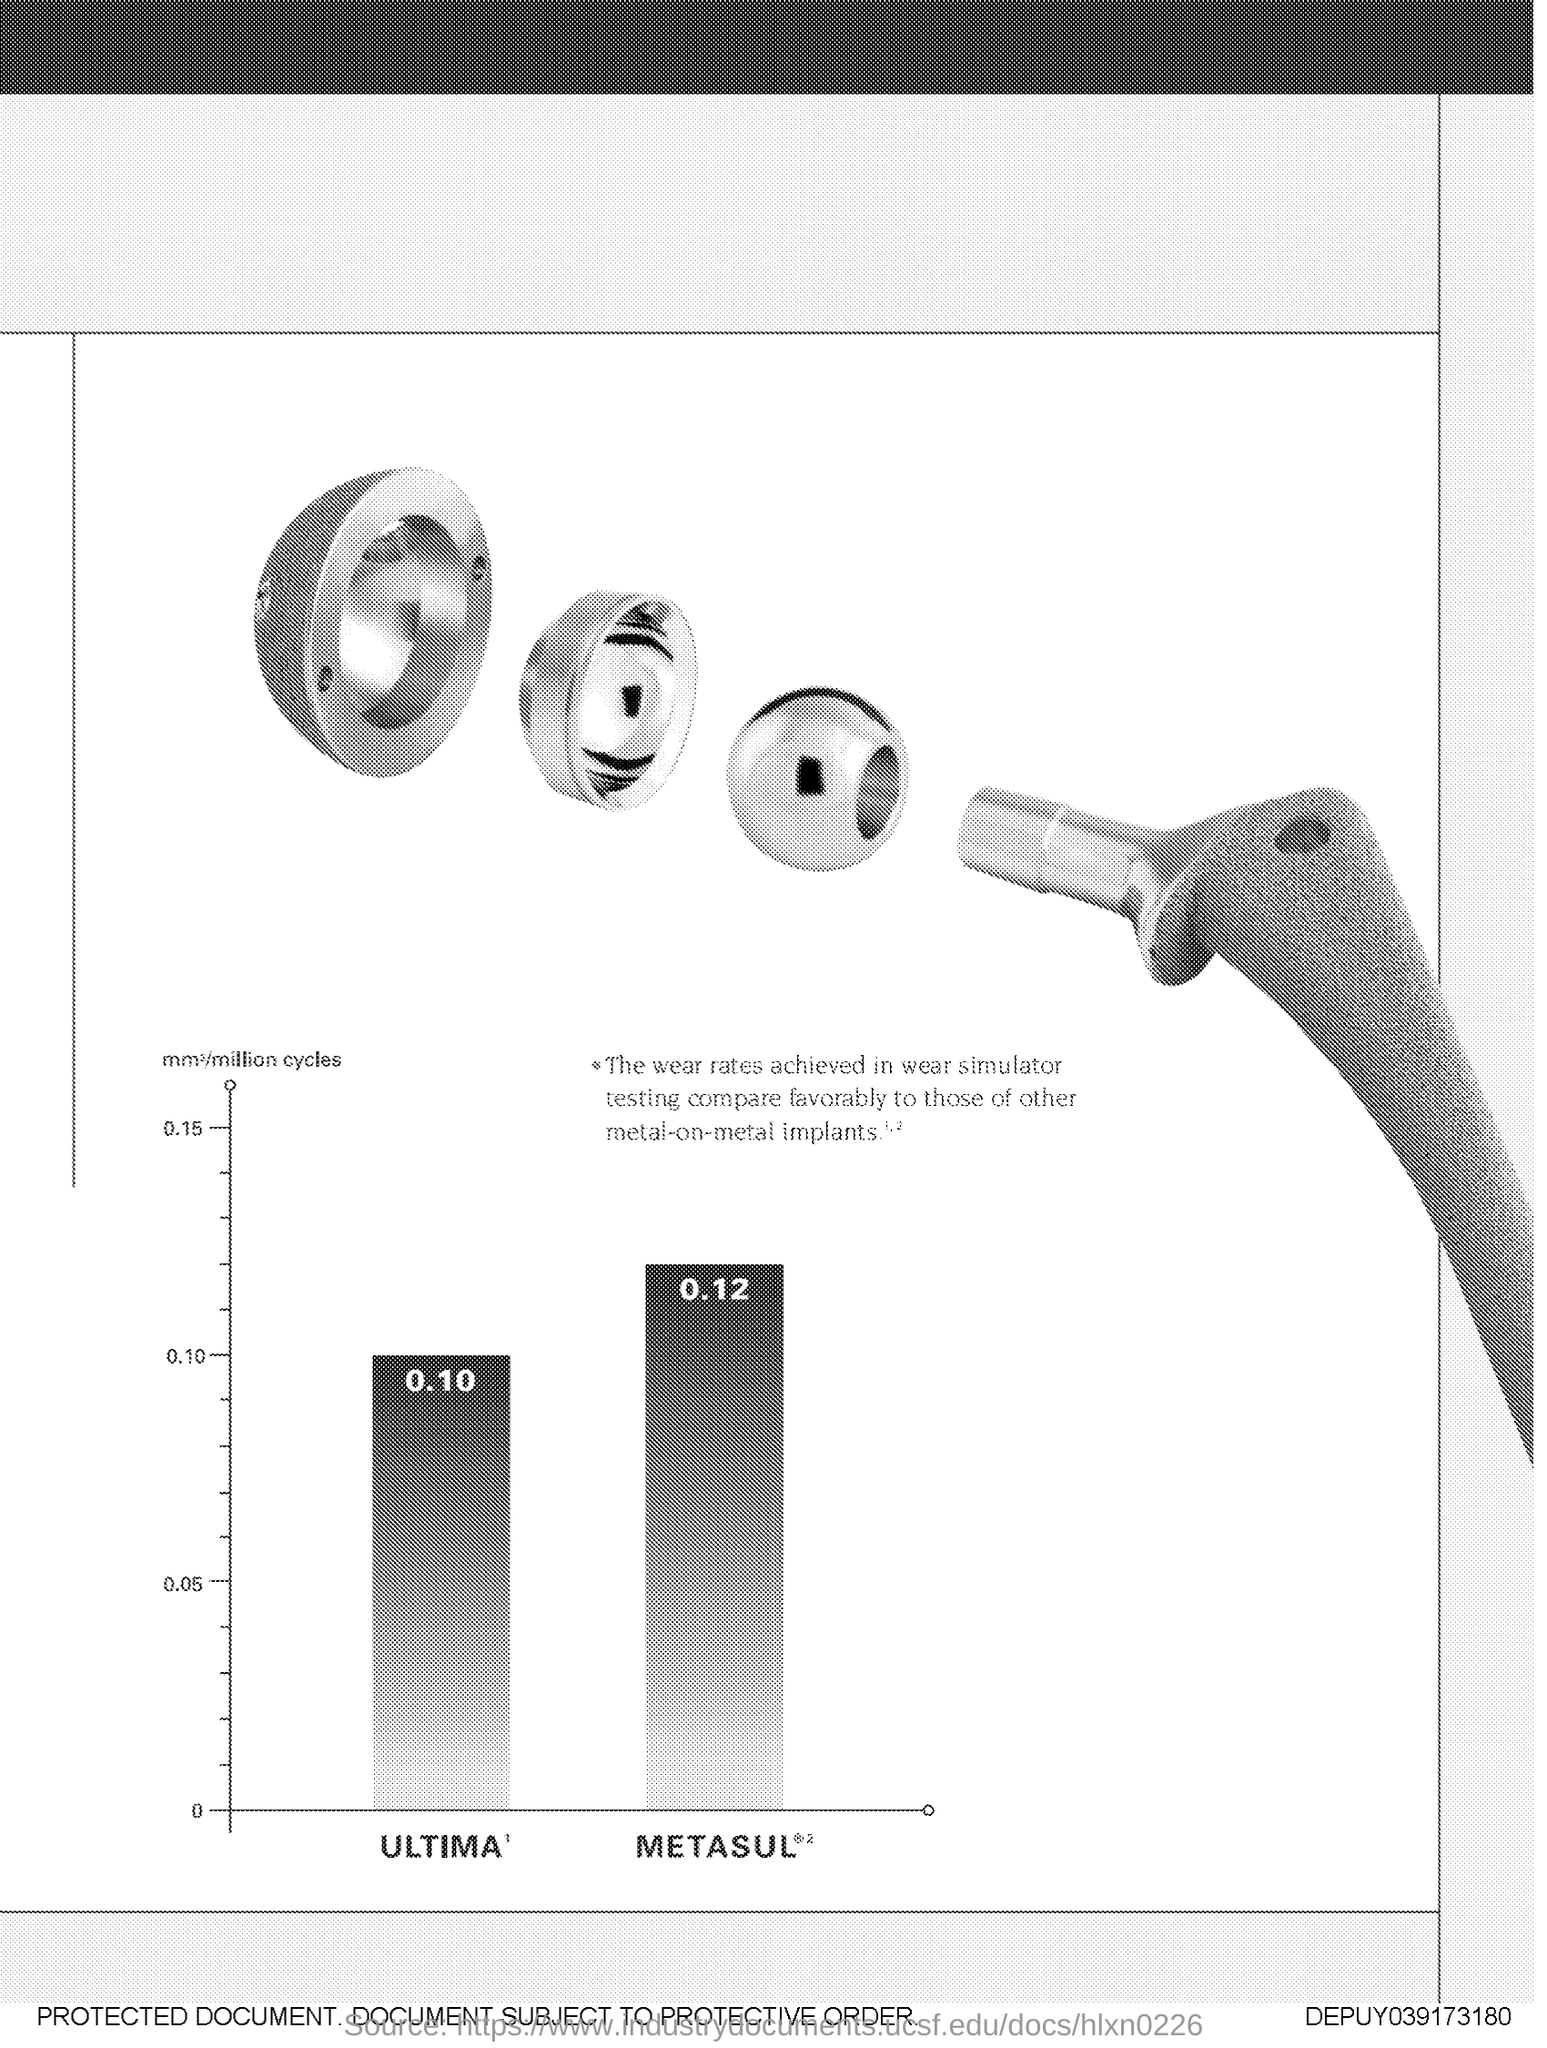Specify some key components in this picture. The highest value plotted on the y-axis is 0.15. 